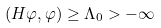Convert formula to latex. <formula><loc_0><loc_0><loc_500><loc_500>( H \varphi , \varphi ) \geq \Lambda _ { 0 } > - \infty</formula> 